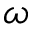Convert formula to latex. <formula><loc_0><loc_0><loc_500><loc_500>\omega</formula> 